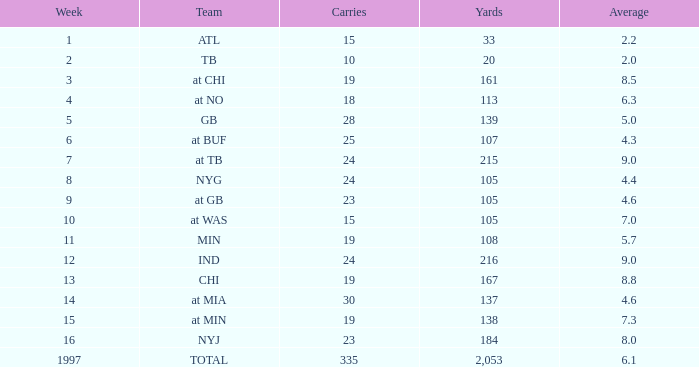Which Average has Yards larger than 167, and a Team of at tb, and a Week larger than 7? None. 